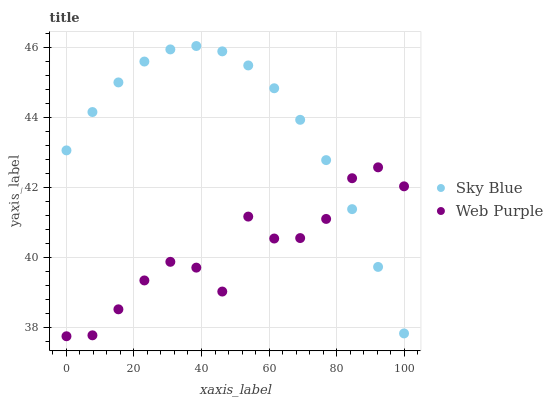Does Web Purple have the minimum area under the curve?
Answer yes or no. Yes. Does Sky Blue have the maximum area under the curve?
Answer yes or no. Yes. Does Web Purple have the maximum area under the curve?
Answer yes or no. No. Is Sky Blue the smoothest?
Answer yes or no. Yes. Is Web Purple the roughest?
Answer yes or no. Yes. Is Web Purple the smoothest?
Answer yes or no. No. Does Web Purple have the lowest value?
Answer yes or no. Yes. Does Sky Blue have the highest value?
Answer yes or no. Yes. Does Web Purple have the highest value?
Answer yes or no. No. Does Sky Blue intersect Web Purple?
Answer yes or no. Yes. Is Sky Blue less than Web Purple?
Answer yes or no. No. Is Sky Blue greater than Web Purple?
Answer yes or no. No. 